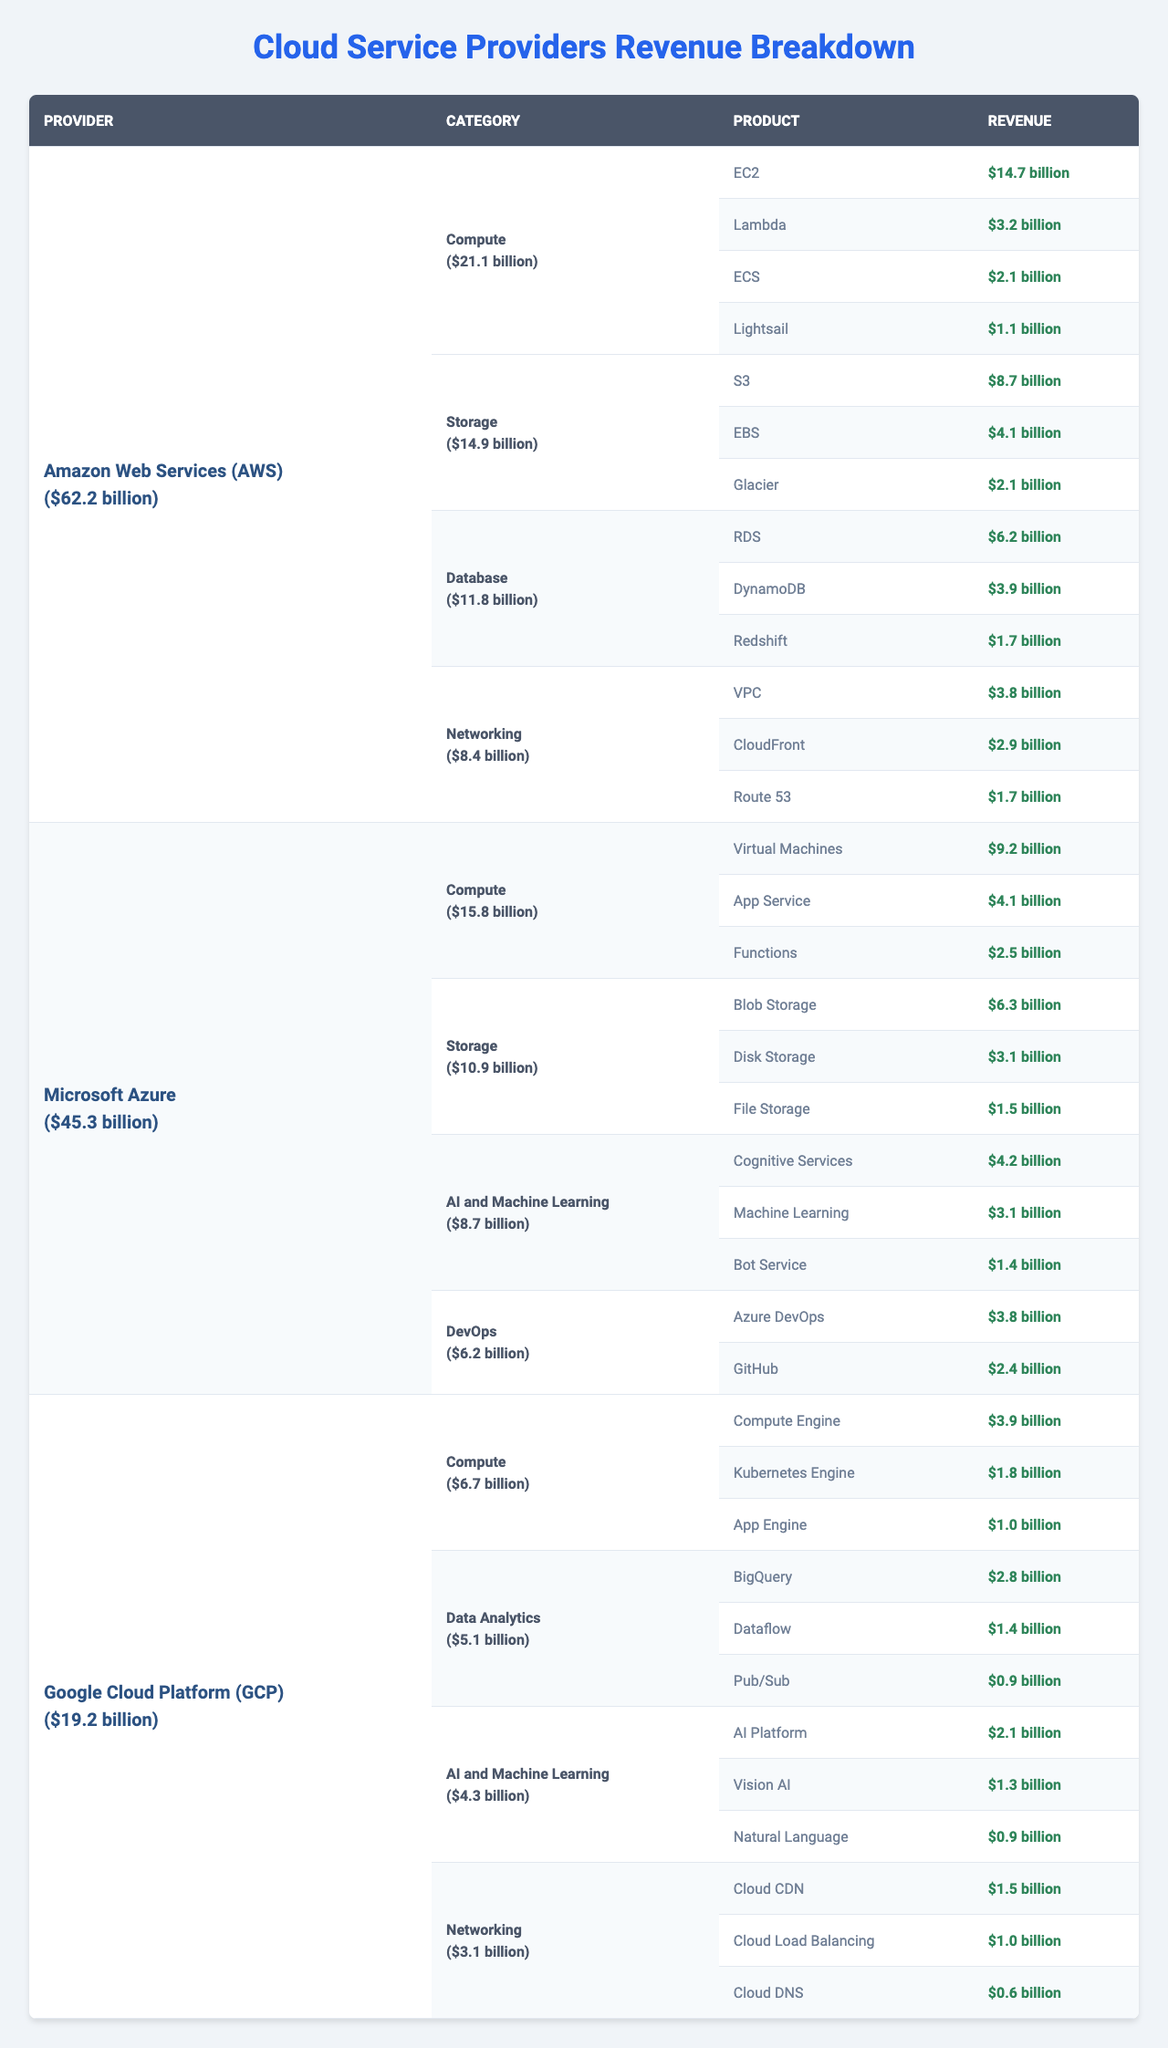What is the total revenue of Amazon Web Services (AWS)? The total revenue for AWS is stated in the table, which is "$62.2 billion."
Answer: $62.2 billion Which product category has the highest revenue in Microsoft Azure? In the table, the revenue for each product category under Microsoft Azure is provided. The highest is "Compute" with revenue of "$15.8 billion."
Answer: Compute How much revenue does Google Cloud Platform (GCP) earn from AI and Machine Learning? The table shows that the AI and Machine Learning category under GCP has a revenue of "$4.3 billion."
Answer: $4.3 billion What are the main storage products provided by Amazon Web Services (AWS)? By reviewing the product categories for AWS, the main products under the "Storage" category are "S3," "EBS," and "Glacier."
Answer: S3, EBS, Glacier Which cloud service provider has the lowest total revenue? Comparing the total revenues of AWS ($62.2 billion), Microsoft Azure ($45.3 billion), and GCP ($19.2 billion) shows that GCP has the lowest.
Answer: Google Cloud Platform (GCP) What is the revenue difference between the "Compute" category of AWS and Microsoft Azure? AWS has $21.1 billion in the Compute category and Microsoft Azure has $15.8 billion. The difference is $21.1 billion - $15.8 billion = $5.3 billion.
Answer: $5.3 billion Does Microsoft Azure offer a product in the "Data Analytics" category? The table lists Microsoft Azure's product categories, and "Data Analytics" is not one of them. So the answer is no.
Answer: No What percentage of AWS's total revenue comes from the "Networking" category? The "Networking" revenue for AWS is $8.4 billion. To find the percentage, divide $8.4 billion by $62.2 billion, which gives approximately 13.5%.
Answer: 13.5% Which provider offers a product named "Bot Service"? Referring to the AI and Machine Learning product category for Microsoft Azure, where "Bot Service" is listed as one of the products.
Answer: Microsoft Azure How much revenue does the "Database" category contribute to AWS compared to Microsoft Azure? AWS's "Database" category contributes $11.8 billion, and Microsoft Azure's total revenue for databases is not listed; thus compared only to AWS, this is the total.
Answer: $11.8 billion 